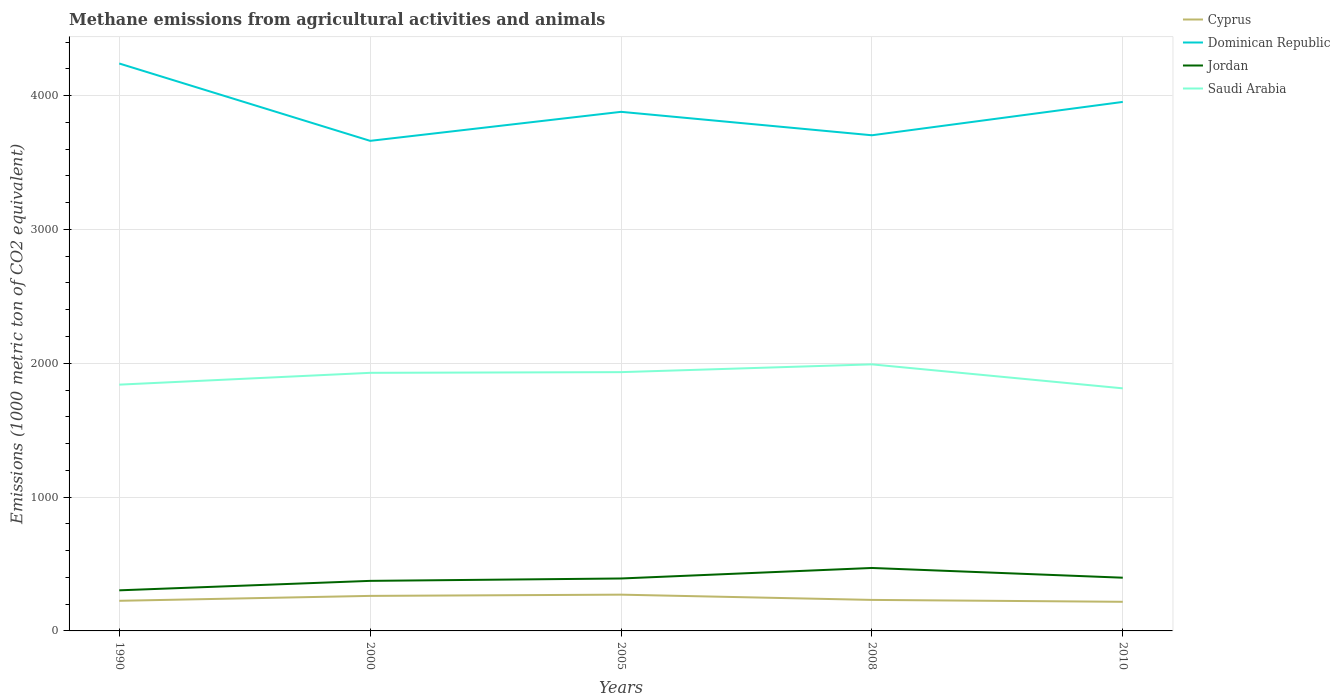How many different coloured lines are there?
Your answer should be very brief. 4. Does the line corresponding to Dominican Republic intersect with the line corresponding to Jordan?
Ensure brevity in your answer.  No. Across all years, what is the maximum amount of methane emitted in Cyprus?
Offer a terse response. 217.6. What is the total amount of methane emitted in Cyprus in the graph?
Ensure brevity in your answer.  53.4. What is the difference between the highest and the second highest amount of methane emitted in Dominican Republic?
Make the answer very short. 578. How many lines are there?
Provide a short and direct response. 4. Are the values on the major ticks of Y-axis written in scientific E-notation?
Your answer should be compact. No. Where does the legend appear in the graph?
Make the answer very short. Top right. How are the legend labels stacked?
Offer a terse response. Vertical. What is the title of the graph?
Make the answer very short. Methane emissions from agricultural activities and animals. Does "High income: nonOECD" appear as one of the legend labels in the graph?
Ensure brevity in your answer.  No. What is the label or title of the X-axis?
Ensure brevity in your answer.  Years. What is the label or title of the Y-axis?
Provide a succinct answer. Emissions (1000 metric ton of CO2 equivalent). What is the Emissions (1000 metric ton of CO2 equivalent) of Cyprus in 1990?
Provide a succinct answer. 225.1. What is the Emissions (1000 metric ton of CO2 equivalent) of Dominican Republic in 1990?
Keep it short and to the point. 4239.8. What is the Emissions (1000 metric ton of CO2 equivalent) of Jordan in 1990?
Your answer should be very brief. 303.3. What is the Emissions (1000 metric ton of CO2 equivalent) of Saudi Arabia in 1990?
Your response must be concise. 1840.2. What is the Emissions (1000 metric ton of CO2 equivalent) in Cyprus in 2000?
Your answer should be compact. 261.7. What is the Emissions (1000 metric ton of CO2 equivalent) in Dominican Republic in 2000?
Give a very brief answer. 3661.8. What is the Emissions (1000 metric ton of CO2 equivalent) of Jordan in 2000?
Your answer should be compact. 374. What is the Emissions (1000 metric ton of CO2 equivalent) in Saudi Arabia in 2000?
Provide a succinct answer. 1928.5. What is the Emissions (1000 metric ton of CO2 equivalent) in Cyprus in 2005?
Provide a short and direct response. 271. What is the Emissions (1000 metric ton of CO2 equivalent) of Dominican Republic in 2005?
Your answer should be very brief. 3878.6. What is the Emissions (1000 metric ton of CO2 equivalent) of Jordan in 2005?
Offer a very short reply. 391.8. What is the Emissions (1000 metric ton of CO2 equivalent) of Saudi Arabia in 2005?
Make the answer very short. 1933.6. What is the Emissions (1000 metric ton of CO2 equivalent) in Cyprus in 2008?
Offer a terse response. 231.7. What is the Emissions (1000 metric ton of CO2 equivalent) in Dominican Republic in 2008?
Make the answer very short. 3703.5. What is the Emissions (1000 metric ton of CO2 equivalent) of Jordan in 2008?
Offer a terse response. 470.4. What is the Emissions (1000 metric ton of CO2 equivalent) of Saudi Arabia in 2008?
Keep it short and to the point. 1991.7. What is the Emissions (1000 metric ton of CO2 equivalent) of Cyprus in 2010?
Your response must be concise. 217.6. What is the Emissions (1000 metric ton of CO2 equivalent) of Dominican Republic in 2010?
Ensure brevity in your answer.  3952.7. What is the Emissions (1000 metric ton of CO2 equivalent) of Jordan in 2010?
Provide a short and direct response. 397.6. What is the Emissions (1000 metric ton of CO2 equivalent) of Saudi Arabia in 2010?
Keep it short and to the point. 1812.5. Across all years, what is the maximum Emissions (1000 metric ton of CO2 equivalent) of Cyprus?
Make the answer very short. 271. Across all years, what is the maximum Emissions (1000 metric ton of CO2 equivalent) of Dominican Republic?
Your answer should be compact. 4239.8. Across all years, what is the maximum Emissions (1000 metric ton of CO2 equivalent) in Jordan?
Your answer should be compact. 470.4. Across all years, what is the maximum Emissions (1000 metric ton of CO2 equivalent) in Saudi Arabia?
Offer a very short reply. 1991.7. Across all years, what is the minimum Emissions (1000 metric ton of CO2 equivalent) of Cyprus?
Your response must be concise. 217.6. Across all years, what is the minimum Emissions (1000 metric ton of CO2 equivalent) of Dominican Republic?
Make the answer very short. 3661.8. Across all years, what is the minimum Emissions (1000 metric ton of CO2 equivalent) of Jordan?
Ensure brevity in your answer.  303.3. Across all years, what is the minimum Emissions (1000 metric ton of CO2 equivalent) in Saudi Arabia?
Your answer should be compact. 1812.5. What is the total Emissions (1000 metric ton of CO2 equivalent) of Cyprus in the graph?
Your answer should be compact. 1207.1. What is the total Emissions (1000 metric ton of CO2 equivalent) in Dominican Republic in the graph?
Make the answer very short. 1.94e+04. What is the total Emissions (1000 metric ton of CO2 equivalent) in Jordan in the graph?
Your response must be concise. 1937.1. What is the total Emissions (1000 metric ton of CO2 equivalent) in Saudi Arabia in the graph?
Your answer should be compact. 9506.5. What is the difference between the Emissions (1000 metric ton of CO2 equivalent) of Cyprus in 1990 and that in 2000?
Keep it short and to the point. -36.6. What is the difference between the Emissions (1000 metric ton of CO2 equivalent) of Dominican Republic in 1990 and that in 2000?
Offer a very short reply. 578. What is the difference between the Emissions (1000 metric ton of CO2 equivalent) in Jordan in 1990 and that in 2000?
Ensure brevity in your answer.  -70.7. What is the difference between the Emissions (1000 metric ton of CO2 equivalent) in Saudi Arabia in 1990 and that in 2000?
Make the answer very short. -88.3. What is the difference between the Emissions (1000 metric ton of CO2 equivalent) of Cyprus in 1990 and that in 2005?
Your response must be concise. -45.9. What is the difference between the Emissions (1000 metric ton of CO2 equivalent) in Dominican Republic in 1990 and that in 2005?
Your answer should be very brief. 361.2. What is the difference between the Emissions (1000 metric ton of CO2 equivalent) of Jordan in 1990 and that in 2005?
Your answer should be very brief. -88.5. What is the difference between the Emissions (1000 metric ton of CO2 equivalent) in Saudi Arabia in 1990 and that in 2005?
Make the answer very short. -93.4. What is the difference between the Emissions (1000 metric ton of CO2 equivalent) in Cyprus in 1990 and that in 2008?
Offer a very short reply. -6.6. What is the difference between the Emissions (1000 metric ton of CO2 equivalent) in Dominican Republic in 1990 and that in 2008?
Offer a terse response. 536.3. What is the difference between the Emissions (1000 metric ton of CO2 equivalent) in Jordan in 1990 and that in 2008?
Ensure brevity in your answer.  -167.1. What is the difference between the Emissions (1000 metric ton of CO2 equivalent) in Saudi Arabia in 1990 and that in 2008?
Offer a terse response. -151.5. What is the difference between the Emissions (1000 metric ton of CO2 equivalent) of Cyprus in 1990 and that in 2010?
Provide a succinct answer. 7.5. What is the difference between the Emissions (1000 metric ton of CO2 equivalent) in Dominican Republic in 1990 and that in 2010?
Offer a terse response. 287.1. What is the difference between the Emissions (1000 metric ton of CO2 equivalent) in Jordan in 1990 and that in 2010?
Give a very brief answer. -94.3. What is the difference between the Emissions (1000 metric ton of CO2 equivalent) in Saudi Arabia in 1990 and that in 2010?
Offer a terse response. 27.7. What is the difference between the Emissions (1000 metric ton of CO2 equivalent) in Dominican Republic in 2000 and that in 2005?
Ensure brevity in your answer.  -216.8. What is the difference between the Emissions (1000 metric ton of CO2 equivalent) of Jordan in 2000 and that in 2005?
Make the answer very short. -17.8. What is the difference between the Emissions (1000 metric ton of CO2 equivalent) in Saudi Arabia in 2000 and that in 2005?
Your answer should be compact. -5.1. What is the difference between the Emissions (1000 metric ton of CO2 equivalent) of Dominican Republic in 2000 and that in 2008?
Your answer should be compact. -41.7. What is the difference between the Emissions (1000 metric ton of CO2 equivalent) of Jordan in 2000 and that in 2008?
Your answer should be very brief. -96.4. What is the difference between the Emissions (1000 metric ton of CO2 equivalent) of Saudi Arabia in 2000 and that in 2008?
Ensure brevity in your answer.  -63.2. What is the difference between the Emissions (1000 metric ton of CO2 equivalent) in Cyprus in 2000 and that in 2010?
Your response must be concise. 44.1. What is the difference between the Emissions (1000 metric ton of CO2 equivalent) of Dominican Republic in 2000 and that in 2010?
Keep it short and to the point. -290.9. What is the difference between the Emissions (1000 metric ton of CO2 equivalent) in Jordan in 2000 and that in 2010?
Your answer should be very brief. -23.6. What is the difference between the Emissions (1000 metric ton of CO2 equivalent) of Saudi Arabia in 2000 and that in 2010?
Give a very brief answer. 116. What is the difference between the Emissions (1000 metric ton of CO2 equivalent) of Cyprus in 2005 and that in 2008?
Ensure brevity in your answer.  39.3. What is the difference between the Emissions (1000 metric ton of CO2 equivalent) of Dominican Republic in 2005 and that in 2008?
Make the answer very short. 175.1. What is the difference between the Emissions (1000 metric ton of CO2 equivalent) of Jordan in 2005 and that in 2008?
Your answer should be very brief. -78.6. What is the difference between the Emissions (1000 metric ton of CO2 equivalent) in Saudi Arabia in 2005 and that in 2008?
Your answer should be compact. -58.1. What is the difference between the Emissions (1000 metric ton of CO2 equivalent) of Cyprus in 2005 and that in 2010?
Ensure brevity in your answer.  53.4. What is the difference between the Emissions (1000 metric ton of CO2 equivalent) of Dominican Republic in 2005 and that in 2010?
Offer a terse response. -74.1. What is the difference between the Emissions (1000 metric ton of CO2 equivalent) in Jordan in 2005 and that in 2010?
Make the answer very short. -5.8. What is the difference between the Emissions (1000 metric ton of CO2 equivalent) of Saudi Arabia in 2005 and that in 2010?
Provide a succinct answer. 121.1. What is the difference between the Emissions (1000 metric ton of CO2 equivalent) of Cyprus in 2008 and that in 2010?
Keep it short and to the point. 14.1. What is the difference between the Emissions (1000 metric ton of CO2 equivalent) in Dominican Republic in 2008 and that in 2010?
Make the answer very short. -249.2. What is the difference between the Emissions (1000 metric ton of CO2 equivalent) in Jordan in 2008 and that in 2010?
Offer a very short reply. 72.8. What is the difference between the Emissions (1000 metric ton of CO2 equivalent) of Saudi Arabia in 2008 and that in 2010?
Offer a very short reply. 179.2. What is the difference between the Emissions (1000 metric ton of CO2 equivalent) in Cyprus in 1990 and the Emissions (1000 metric ton of CO2 equivalent) in Dominican Republic in 2000?
Your answer should be very brief. -3436.7. What is the difference between the Emissions (1000 metric ton of CO2 equivalent) of Cyprus in 1990 and the Emissions (1000 metric ton of CO2 equivalent) of Jordan in 2000?
Make the answer very short. -148.9. What is the difference between the Emissions (1000 metric ton of CO2 equivalent) in Cyprus in 1990 and the Emissions (1000 metric ton of CO2 equivalent) in Saudi Arabia in 2000?
Make the answer very short. -1703.4. What is the difference between the Emissions (1000 metric ton of CO2 equivalent) in Dominican Republic in 1990 and the Emissions (1000 metric ton of CO2 equivalent) in Jordan in 2000?
Your answer should be very brief. 3865.8. What is the difference between the Emissions (1000 metric ton of CO2 equivalent) in Dominican Republic in 1990 and the Emissions (1000 metric ton of CO2 equivalent) in Saudi Arabia in 2000?
Your response must be concise. 2311.3. What is the difference between the Emissions (1000 metric ton of CO2 equivalent) of Jordan in 1990 and the Emissions (1000 metric ton of CO2 equivalent) of Saudi Arabia in 2000?
Provide a short and direct response. -1625.2. What is the difference between the Emissions (1000 metric ton of CO2 equivalent) in Cyprus in 1990 and the Emissions (1000 metric ton of CO2 equivalent) in Dominican Republic in 2005?
Your response must be concise. -3653.5. What is the difference between the Emissions (1000 metric ton of CO2 equivalent) in Cyprus in 1990 and the Emissions (1000 metric ton of CO2 equivalent) in Jordan in 2005?
Make the answer very short. -166.7. What is the difference between the Emissions (1000 metric ton of CO2 equivalent) of Cyprus in 1990 and the Emissions (1000 metric ton of CO2 equivalent) of Saudi Arabia in 2005?
Make the answer very short. -1708.5. What is the difference between the Emissions (1000 metric ton of CO2 equivalent) in Dominican Republic in 1990 and the Emissions (1000 metric ton of CO2 equivalent) in Jordan in 2005?
Your response must be concise. 3848. What is the difference between the Emissions (1000 metric ton of CO2 equivalent) in Dominican Republic in 1990 and the Emissions (1000 metric ton of CO2 equivalent) in Saudi Arabia in 2005?
Provide a short and direct response. 2306.2. What is the difference between the Emissions (1000 metric ton of CO2 equivalent) in Jordan in 1990 and the Emissions (1000 metric ton of CO2 equivalent) in Saudi Arabia in 2005?
Your answer should be very brief. -1630.3. What is the difference between the Emissions (1000 metric ton of CO2 equivalent) in Cyprus in 1990 and the Emissions (1000 metric ton of CO2 equivalent) in Dominican Republic in 2008?
Give a very brief answer. -3478.4. What is the difference between the Emissions (1000 metric ton of CO2 equivalent) in Cyprus in 1990 and the Emissions (1000 metric ton of CO2 equivalent) in Jordan in 2008?
Ensure brevity in your answer.  -245.3. What is the difference between the Emissions (1000 metric ton of CO2 equivalent) in Cyprus in 1990 and the Emissions (1000 metric ton of CO2 equivalent) in Saudi Arabia in 2008?
Make the answer very short. -1766.6. What is the difference between the Emissions (1000 metric ton of CO2 equivalent) in Dominican Republic in 1990 and the Emissions (1000 metric ton of CO2 equivalent) in Jordan in 2008?
Ensure brevity in your answer.  3769.4. What is the difference between the Emissions (1000 metric ton of CO2 equivalent) of Dominican Republic in 1990 and the Emissions (1000 metric ton of CO2 equivalent) of Saudi Arabia in 2008?
Provide a short and direct response. 2248.1. What is the difference between the Emissions (1000 metric ton of CO2 equivalent) in Jordan in 1990 and the Emissions (1000 metric ton of CO2 equivalent) in Saudi Arabia in 2008?
Your answer should be very brief. -1688.4. What is the difference between the Emissions (1000 metric ton of CO2 equivalent) of Cyprus in 1990 and the Emissions (1000 metric ton of CO2 equivalent) of Dominican Republic in 2010?
Give a very brief answer. -3727.6. What is the difference between the Emissions (1000 metric ton of CO2 equivalent) in Cyprus in 1990 and the Emissions (1000 metric ton of CO2 equivalent) in Jordan in 2010?
Your answer should be compact. -172.5. What is the difference between the Emissions (1000 metric ton of CO2 equivalent) of Cyprus in 1990 and the Emissions (1000 metric ton of CO2 equivalent) of Saudi Arabia in 2010?
Offer a terse response. -1587.4. What is the difference between the Emissions (1000 metric ton of CO2 equivalent) in Dominican Republic in 1990 and the Emissions (1000 metric ton of CO2 equivalent) in Jordan in 2010?
Make the answer very short. 3842.2. What is the difference between the Emissions (1000 metric ton of CO2 equivalent) of Dominican Republic in 1990 and the Emissions (1000 metric ton of CO2 equivalent) of Saudi Arabia in 2010?
Offer a terse response. 2427.3. What is the difference between the Emissions (1000 metric ton of CO2 equivalent) in Jordan in 1990 and the Emissions (1000 metric ton of CO2 equivalent) in Saudi Arabia in 2010?
Make the answer very short. -1509.2. What is the difference between the Emissions (1000 metric ton of CO2 equivalent) in Cyprus in 2000 and the Emissions (1000 metric ton of CO2 equivalent) in Dominican Republic in 2005?
Make the answer very short. -3616.9. What is the difference between the Emissions (1000 metric ton of CO2 equivalent) in Cyprus in 2000 and the Emissions (1000 metric ton of CO2 equivalent) in Jordan in 2005?
Offer a terse response. -130.1. What is the difference between the Emissions (1000 metric ton of CO2 equivalent) in Cyprus in 2000 and the Emissions (1000 metric ton of CO2 equivalent) in Saudi Arabia in 2005?
Offer a terse response. -1671.9. What is the difference between the Emissions (1000 metric ton of CO2 equivalent) of Dominican Republic in 2000 and the Emissions (1000 metric ton of CO2 equivalent) of Jordan in 2005?
Make the answer very short. 3270. What is the difference between the Emissions (1000 metric ton of CO2 equivalent) of Dominican Republic in 2000 and the Emissions (1000 metric ton of CO2 equivalent) of Saudi Arabia in 2005?
Your answer should be compact. 1728.2. What is the difference between the Emissions (1000 metric ton of CO2 equivalent) in Jordan in 2000 and the Emissions (1000 metric ton of CO2 equivalent) in Saudi Arabia in 2005?
Your response must be concise. -1559.6. What is the difference between the Emissions (1000 metric ton of CO2 equivalent) of Cyprus in 2000 and the Emissions (1000 metric ton of CO2 equivalent) of Dominican Republic in 2008?
Offer a very short reply. -3441.8. What is the difference between the Emissions (1000 metric ton of CO2 equivalent) of Cyprus in 2000 and the Emissions (1000 metric ton of CO2 equivalent) of Jordan in 2008?
Keep it short and to the point. -208.7. What is the difference between the Emissions (1000 metric ton of CO2 equivalent) of Cyprus in 2000 and the Emissions (1000 metric ton of CO2 equivalent) of Saudi Arabia in 2008?
Offer a very short reply. -1730. What is the difference between the Emissions (1000 metric ton of CO2 equivalent) of Dominican Republic in 2000 and the Emissions (1000 metric ton of CO2 equivalent) of Jordan in 2008?
Provide a short and direct response. 3191.4. What is the difference between the Emissions (1000 metric ton of CO2 equivalent) in Dominican Republic in 2000 and the Emissions (1000 metric ton of CO2 equivalent) in Saudi Arabia in 2008?
Make the answer very short. 1670.1. What is the difference between the Emissions (1000 metric ton of CO2 equivalent) of Jordan in 2000 and the Emissions (1000 metric ton of CO2 equivalent) of Saudi Arabia in 2008?
Give a very brief answer. -1617.7. What is the difference between the Emissions (1000 metric ton of CO2 equivalent) in Cyprus in 2000 and the Emissions (1000 metric ton of CO2 equivalent) in Dominican Republic in 2010?
Give a very brief answer. -3691. What is the difference between the Emissions (1000 metric ton of CO2 equivalent) of Cyprus in 2000 and the Emissions (1000 metric ton of CO2 equivalent) of Jordan in 2010?
Provide a short and direct response. -135.9. What is the difference between the Emissions (1000 metric ton of CO2 equivalent) of Cyprus in 2000 and the Emissions (1000 metric ton of CO2 equivalent) of Saudi Arabia in 2010?
Provide a short and direct response. -1550.8. What is the difference between the Emissions (1000 metric ton of CO2 equivalent) of Dominican Republic in 2000 and the Emissions (1000 metric ton of CO2 equivalent) of Jordan in 2010?
Offer a terse response. 3264.2. What is the difference between the Emissions (1000 metric ton of CO2 equivalent) of Dominican Republic in 2000 and the Emissions (1000 metric ton of CO2 equivalent) of Saudi Arabia in 2010?
Give a very brief answer. 1849.3. What is the difference between the Emissions (1000 metric ton of CO2 equivalent) in Jordan in 2000 and the Emissions (1000 metric ton of CO2 equivalent) in Saudi Arabia in 2010?
Give a very brief answer. -1438.5. What is the difference between the Emissions (1000 metric ton of CO2 equivalent) of Cyprus in 2005 and the Emissions (1000 metric ton of CO2 equivalent) of Dominican Republic in 2008?
Ensure brevity in your answer.  -3432.5. What is the difference between the Emissions (1000 metric ton of CO2 equivalent) of Cyprus in 2005 and the Emissions (1000 metric ton of CO2 equivalent) of Jordan in 2008?
Offer a terse response. -199.4. What is the difference between the Emissions (1000 metric ton of CO2 equivalent) in Cyprus in 2005 and the Emissions (1000 metric ton of CO2 equivalent) in Saudi Arabia in 2008?
Offer a very short reply. -1720.7. What is the difference between the Emissions (1000 metric ton of CO2 equivalent) of Dominican Republic in 2005 and the Emissions (1000 metric ton of CO2 equivalent) of Jordan in 2008?
Give a very brief answer. 3408.2. What is the difference between the Emissions (1000 metric ton of CO2 equivalent) of Dominican Republic in 2005 and the Emissions (1000 metric ton of CO2 equivalent) of Saudi Arabia in 2008?
Provide a short and direct response. 1886.9. What is the difference between the Emissions (1000 metric ton of CO2 equivalent) of Jordan in 2005 and the Emissions (1000 metric ton of CO2 equivalent) of Saudi Arabia in 2008?
Ensure brevity in your answer.  -1599.9. What is the difference between the Emissions (1000 metric ton of CO2 equivalent) of Cyprus in 2005 and the Emissions (1000 metric ton of CO2 equivalent) of Dominican Republic in 2010?
Keep it short and to the point. -3681.7. What is the difference between the Emissions (1000 metric ton of CO2 equivalent) in Cyprus in 2005 and the Emissions (1000 metric ton of CO2 equivalent) in Jordan in 2010?
Ensure brevity in your answer.  -126.6. What is the difference between the Emissions (1000 metric ton of CO2 equivalent) of Cyprus in 2005 and the Emissions (1000 metric ton of CO2 equivalent) of Saudi Arabia in 2010?
Your answer should be very brief. -1541.5. What is the difference between the Emissions (1000 metric ton of CO2 equivalent) in Dominican Republic in 2005 and the Emissions (1000 metric ton of CO2 equivalent) in Jordan in 2010?
Ensure brevity in your answer.  3481. What is the difference between the Emissions (1000 metric ton of CO2 equivalent) of Dominican Republic in 2005 and the Emissions (1000 metric ton of CO2 equivalent) of Saudi Arabia in 2010?
Your answer should be very brief. 2066.1. What is the difference between the Emissions (1000 metric ton of CO2 equivalent) in Jordan in 2005 and the Emissions (1000 metric ton of CO2 equivalent) in Saudi Arabia in 2010?
Your response must be concise. -1420.7. What is the difference between the Emissions (1000 metric ton of CO2 equivalent) in Cyprus in 2008 and the Emissions (1000 metric ton of CO2 equivalent) in Dominican Republic in 2010?
Your answer should be compact. -3721. What is the difference between the Emissions (1000 metric ton of CO2 equivalent) in Cyprus in 2008 and the Emissions (1000 metric ton of CO2 equivalent) in Jordan in 2010?
Offer a very short reply. -165.9. What is the difference between the Emissions (1000 metric ton of CO2 equivalent) of Cyprus in 2008 and the Emissions (1000 metric ton of CO2 equivalent) of Saudi Arabia in 2010?
Provide a short and direct response. -1580.8. What is the difference between the Emissions (1000 metric ton of CO2 equivalent) in Dominican Republic in 2008 and the Emissions (1000 metric ton of CO2 equivalent) in Jordan in 2010?
Keep it short and to the point. 3305.9. What is the difference between the Emissions (1000 metric ton of CO2 equivalent) of Dominican Republic in 2008 and the Emissions (1000 metric ton of CO2 equivalent) of Saudi Arabia in 2010?
Ensure brevity in your answer.  1891. What is the difference between the Emissions (1000 metric ton of CO2 equivalent) of Jordan in 2008 and the Emissions (1000 metric ton of CO2 equivalent) of Saudi Arabia in 2010?
Provide a short and direct response. -1342.1. What is the average Emissions (1000 metric ton of CO2 equivalent) of Cyprus per year?
Provide a succinct answer. 241.42. What is the average Emissions (1000 metric ton of CO2 equivalent) in Dominican Republic per year?
Make the answer very short. 3887.28. What is the average Emissions (1000 metric ton of CO2 equivalent) of Jordan per year?
Your response must be concise. 387.42. What is the average Emissions (1000 metric ton of CO2 equivalent) in Saudi Arabia per year?
Make the answer very short. 1901.3. In the year 1990, what is the difference between the Emissions (1000 metric ton of CO2 equivalent) of Cyprus and Emissions (1000 metric ton of CO2 equivalent) of Dominican Republic?
Your answer should be compact. -4014.7. In the year 1990, what is the difference between the Emissions (1000 metric ton of CO2 equivalent) in Cyprus and Emissions (1000 metric ton of CO2 equivalent) in Jordan?
Keep it short and to the point. -78.2. In the year 1990, what is the difference between the Emissions (1000 metric ton of CO2 equivalent) of Cyprus and Emissions (1000 metric ton of CO2 equivalent) of Saudi Arabia?
Your answer should be very brief. -1615.1. In the year 1990, what is the difference between the Emissions (1000 metric ton of CO2 equivalent) in Dominican Republic and Emissions (1000 metric ton of CO2 equivalent) in Jordan?
Give a very brief answer. 3936.5. In the year 1990, what is the difference between the Emissions (1000 metric ton of CO2 equivalent) in Dominican Republic and Emissions (1000 metric ton of CO2 equivalent) in Saudi Arabia?
Your answer should be compact. 2399.6. In the year 1990, what is the difference between the Emissions (1000 metric ton of CO2 equivalent) in Jordan and Emissions (1000 metric ton of CO2 equivalent) in Saudi Arabia?
Keep it short and to the point. -1536.9. In the year 2000, what is the difference between the Emissions (1000 metric ton of CO2 equivalent) in Cyprus and Emissions (1000 metric ton of CO2 equivalent) in Dominican Republic?
Give a very brief answer. -3400.1. In the year 2000, what is the difference between the Emissions (1000 metric ton of CO2 equivalent) in Cyprus and Emissions (1000 metric ton of CO2 equivalent) in Jordan?
Offer a terse response. -112.3. In the year 2000, what is the difference between the Emissions (1000 metric ton of CO2 equivalent) of Cyprus and Emissions (1000 metric ton of CO2 equivalent) of Saudi Arabia?
Give a very brief answer. -1666.8. In the year 2000, what is the difference between the Emissions (1000 metric ton of CO2 equivalent) in Dominican Republic and Emissions (1000 metric ton of CO2 equivalent) in Jordan?
Offer a very short reply. 3287.8. In the year 2000, what is the difference between the Emissions (1000 metric ton of CO2 equivalent) in Dominican Republic and Emissions (1000 metric ton of CO2 equivalent) in Saudi Arabia?
Give a very brief answer. 1733.3. In the year 2000, what is the difference between the Emissions (1000 metric ton of CO2 equivalent) of Jordan and Emissions (1000 metric ton of CO2 equivalent) of Saudi Arabia?
Ensure brevity in your answer.  -1554.5. In the year 2005, what is the difference between the Emissions (1000 metric ton of CO2 equivalent) in Cyprus and Emissions (1000 metric ton of CO2 equivalent) in Dominican Republic?
Ensure brevity in your answer.  -3607.6. In the year 2005, what is the difference between the Emissions (1000 metric ton of CO2 equivalent) in Cyprus and Emissions (1000 metric ton of CO2 equivalent) in Jordan?
Provide a short and direct response. -120.8. In the year 2005, what is the difference between the Emissions (1000 metric ton of CO2 equivalent) of Cyprus and Emissions (1000 metric ton of CO2 equivalent) of Saudi Arabia?
Your answer should be compact. -1662.6. In the year 2005, what is the difference between the Emissions (1000 metric ton of CO2 equivalent) in Dominican Republic and Emissions (1000 metric ton of CO2 equivalent) in Jordan?
Ensure brevity in your answer.  3486.8. In the year 2005, what is the difference between the Emissions (1000 metric ton of CO2 equivalent) in Dominican Republic and Emissions (1000 metric ton of CO2 equivalent) in Saudi Arabia?
Offer a terse response. 1945. In the year 2005, what is the difference between the Emissions (1000 metric ton of CO2 equivalent) in Jordan and Emissions (1000 metric ton of CO2 equivalent) in Saudi Arabia?
Give a very brief answer. -1541.8. In the year 2008, what is the difference between the Emissions (1000 metric ton of CO2 equivalent) of Cyprus and Emissions (1000 metric ton of CO2 equivalent) of Dominican Republic?
Your response must be concise. -3471.8. In the year 2008, what is the difference between the Emissions (1000 metric ton of CO2 equivalent) of Cyprus and Emissions (1000 metric ton of CO2 equivalent) of Jordan?
Provide a short and direct response. -238.7. In the year 2008, what is the difference between the Emissions (1000 metric ton of CO2 equivalent) in Cyprus and Emissions (1000 metric ton of CO2 equivalent) in Saudi Arabia?
Keep it short and to the point. -1760. In the year 2008, what is the difference between the Emissions (1000 metric ton of CO2 equivalent) in Dominican Republic and Emissions (1000 metric ton of CO2 equivalent) in Jordan?
Provide a succinct answer. 3233.1. In the year 2008, what is the difference between the Emissions (1000 metric ton of CO2 equivalent) in Dominican Republic and Emissions (1000 metric ton of CO2 equivalent) in Saudi Arabia?
Your answer should be very brief. 1711.8. In the year 2008, what is the difference between the Emissions (1000 metric ton of CO2 equivalent) of Jordan and Emissions (1000 metric ton of CO2 equivalent) of Saudi Arabia?
Provide a succinct answer. -1521.3. In the year 2010, what is the difference between the Emissions (1000 metric ton of CO2 equivalent) of Cyprus and Emissions (1000 metric ton of CO2 equivalent) of Dominican Republic?
Provide a succinct answer. -3735.1. In the year 2010, what is the difference between the Emissions (1000 metric ton of CO2 equivalent) of Cyprus and Emissions (1000 metric ton of CO2 equivalent) of Jordan?
Ensure brevity in your answer.  -180. In the year 2010, what is the difference between the Emissions (1000 metric ton of CO2 equivalent) in Cyprus and Emissions (1000 metric ton of CO2 equivalent) in Saudi Arabia?
Your response must be concise. -1594.9. In the year 2010, what is the difference between the Emissions (1000 metric ton of CO2 equivalent) in Dominican Republic and Emissions (1000 metric ton of CO2 equivalent) in Jordan?
Offer a very short reply. 3555.1. In the year 2010, what is the difference between the Emissions (1000 metric ton of CO2 equivalent) in Dominican Republic and Emissions (1000 metric ton of CO2 equivalent) in Saudi Arabia?
Give a very brief answer. 2140.2. In the year 2010, what is the difference between the Emissions (1000 metric ton of CO2 equivalent) of Jordan and Emissions (1000 metric ton of CO2 equivalent) of Saudi Arabia?
Give a very brief answer. -1414.9. What is the ratio of the Emissions (1000 metric ton of CO2 equivalent) of Cyprus in 1990 to that in 2000?
Offer a very short reply. 0.86. What is the ratio of the Emissions (1000 metric ton of CO2 equivalent) in Dominican Republic in 1990 to that in 2000?
Your response must be concise. 1.16. What is the ratio of the Emissions (1000 metric ton of CO2 equivalent) of Jordan in 1990 to that in 2000?
Offer a very short reply. 0.81. What is the ratio of the Emissions (1000 metric ton of CO2 equivalent) of Saudi Arabia in 1990 to that in 2000?
Your answer should be very brief. 0.95. What is the ratio of the Emissions (1000 metric ton of CO2 equivalent) of Cyprus in 1990 to that in 2005?
Your answer should be compact. 0.83. What is the ratio of the Emissions (1000 metric ton of CO2 equivalent) in Dominican Republic in 1990 to that in 2005?
Keep it short and to the point. 1.09. What is the ratio of the Emissions (1000 metric ton of CO2 equivalent) in Jordan in 1990 to that in 2005?
Give a very brief answer. 0.77. What is the ratio of the Emissions (1000 metric ton of CO2 equivalent) in Saudi Arabia in 1990 to that in 2005?
Keep it short and to the point. 0.95. What is the ratio of the Emissions (1000 metric ton of CO2 equivalent) in Cyprus in 1990 to that in 2008?
Offer a very short reply. 0.97. What is the ratio of the Emissions (1000 metric ton of CO2 equivalent) of Dominican Republic in 1990 to that in 2008?
Make the answer very short. 1.14. What is the ratio of the Emissions (1000 metric ton of CO2 equivalent) of Jordan in 1990 to that in 2008?
Your answer should be compact. 0.64. What is the ratio of the Emissions (1000 metric ton of CO2 equivalent) in Saudi Arabia in 1990 to that in 2008?
Give a very brief answer. 0.92. What is the ratio of the Emissions (1000 metric ton of CO2 equivalent) of Cyprus in 1990 to that in 2010?
Your response must be concise. 1.03. What is the ratio of the Emissions (1000 metric ton of CO2 equivalent) of Dominican Republic in 1990 to that in 2010?
Provide a short and direct response. 1.07. What is the ratio of the Emissions (1000 metric ton of CO2 equivalent) of Jordan in 1990 to that in 2010?
Provide a short and direct response. 0.76. What is the ratio of the Emissions (1000 metric ton of CO2 equivalent) in Saudi Arabia in 1990 to that in 2010?
Keep it short and to the point. 1.02. What is the ratio of the Emissions (1000 metric ton of CO2 equivalent) of Cyprus in 2000 to that in 2005?
Your answer should be very brief. 0.97. What is the ratio of the Emissions (1000 metric ton of CO2 equivalent) in Dominican Republic in 2000 to that in 2005?
Make the answer very short. 0.94. What is the ratio of the Emissions (1000 metric ton of CO2 equivalent) in Jordan in 2000 to that in 2005?
Make the answer very short. 0.95. What is the ratio of the Emissions (1000 metric ton of CO2 equivalent) in Cyprus in 2000 to that in 2008?
Your response must be concise. 1.13. What is the ratio of the Emissions (1000 metric ton of CO2 equivalent) in Dominican Republic in 2000 to that in 2008?
Provide a succinct answer. 0.99. What is the ratio of the Emissions (1000 metric ton of CO2 equivalent) of Jordan in 2000 to that in 2008?
Provide a short and direct response. 0.8. What is the ratio of the Emissions (1000 metric ton of CO2 equivalent) of Saudi Arabia in 2000 to that in 2008?
Make the answer very short. 0.97. What is the ratio of the Emissions (1000 metric ton of CO2 equivalent) in Cyprus in 2000 to that in 2010?
Your answer should be compact. 1.2. What is the ratio of the Emissions (1000 metric ton of CO2 equivalent) in Dominican Republic in 2000 to that in 2010?
Provide a succinct answer. 0.93. What is the ratio of the Emissions (1000 metric ton of CO2 equivalent) in Jordan in 2000 to that in 2010?
Provide a short and direct response. 0.94. What is the ratio of the Emissions (1000 metric ton of CO2 equivalent) of Saudi Arabia in 2000 to that in 2010?
Provide a succinct answer. 1.06. What is the ratio of the Emissions (1000 metric ton of CO2 equivalent) of Cyprus in 2005 to that in 2008?
Offer a terse response. 1.17. What is the ratio of the Emissions (1000 metric ton of CO2 equivalent) of Dominican Republic in 2005 to that in 2008?
Provide a short and direct response. 1.05. What is the ratio of the Emissions (1000 metric ton of CO2 equivalent) of Jordan in 2005 to that in 2008?
Your answer should be very brief. 0.83. What is the ratio of the Emissions (1000 metric ton of CO2 equivalent) of Saudi Arabia in 2005 to that in 2008?
Provide a succinct answer. 0.97. What is the ratio of the Emissions (1000 metric ton of CO2 equivalent) of Cyprus in 2005 to that in 2010?
Provide a succinct answer. 1.25. What is the ratio of the Emissions (1000 metric ton of CO2 equivalent) of Dominican Republic in 2005 to that in 2010?
Your response must be concise. 0.98. What is the ratio of the Emissions (1000 metric ton of CO2 equivalent) in Jordan in 2005 to that in 2010?
Give a very brief answer. 0.99. What is the ratio of the Emissions (1000 metric ton of CO2 equivalent) in Saudi Arabia in 2005 to that in 2010?
Make the answer very short. 1.07. What is the ratio of the Emissions (1000 metric ton of CO2 equivalent) of Cyprus in 2008 to that in 2010?
Offer a very short reply. 1.06. What is the ratio of the Emissions (1000 metric ton of CO2 equivalent) in Dominican Republic in 2008 to that in 2010?
Provide a succinct answer. 0.94. What is the ratio of the Emissions (1000 metric ton of CO2 equivalent) in Jordan in 2008 to that in 2010?
Your answer should be compact. 1.18. What is the ratio of the Emissions (1000 metric ton of CO2 equivalent) of Saudi Arabia in 2008 to that in 2010?
Keep it short and to the point. 1.1. What is the difference between the highest and the second highest Emissions (1000 metric ton of CO2 equivalent) of Cyprus?
Provide a short and direct response. 9.3. What is the difference between the highest and the second highest Emissions (1000 metric ton of CO2 equivalent) in Dominican Republic?
Your answer should be compact. 287.1. What is the difference between the highest and the second highest Emissions (1000 metric ton of CO2 equivalent) in Jordan?
Give a very brief answer. 72.8. What is the difference between the highest and the second highest Emissions (1000 metric ton of CO2 equivalent) in Saudi Arabia?
Your response must be concise. 58.1. What is the difference between the highest and the lowest Emissions (1000 metric ton of CO2 equivalent) in Cyprus?
Offer a very short reply. 53.4. What is the difference between the highest and the lowest Emissions (1000 metric ton of CO2 equivalent) in Dominican Republic?
Your response must be concise. 578. What is the difference between the highest and the lowest Emissions (1000 metric ton of CO2 equivalent) of Jordan?
Ensure brevity in your answer.  167.1. What is the difference between the highest and the lowest Emissions (1000 metric ton of CO2 equivalent) of Saudi Arabia?
Keep it short and to the point. 179.2. 